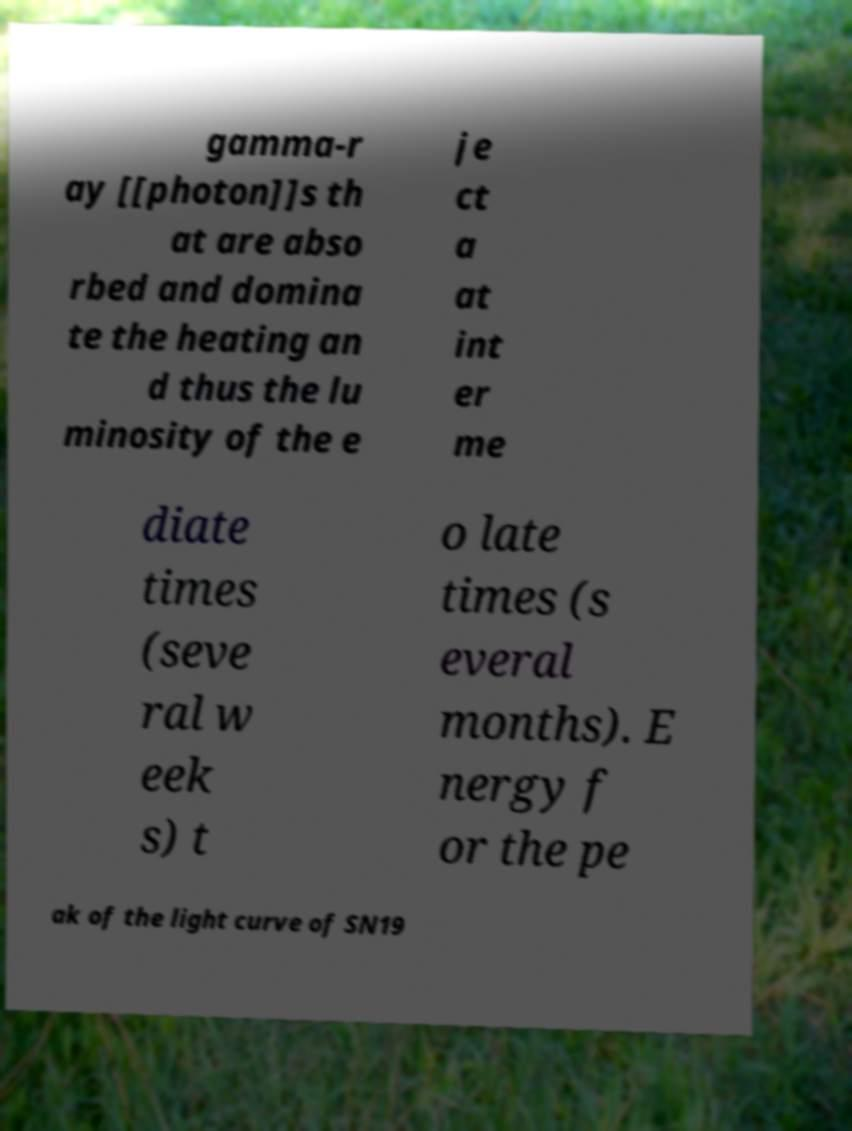Please identify and transcribe the text found in this image. gamma-r ay [[photon]]s th at are abso rbed and domina te the heating an d thus the lu minosity of the e je ct a at int er me diate times (seve ral w eek s) t o late times (s everal months). E nergy f or the pe ak of the light curve of SN19 